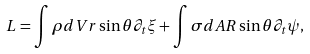Convert formula to latex. <formula><loc_0><loc_0><loc_500><loc_500>L = \int \rho d V r \sin \theta \partial _ { t } \xi + \int \sigma d A R \sin \theta \partial _ { t } \psi ,</formula> 